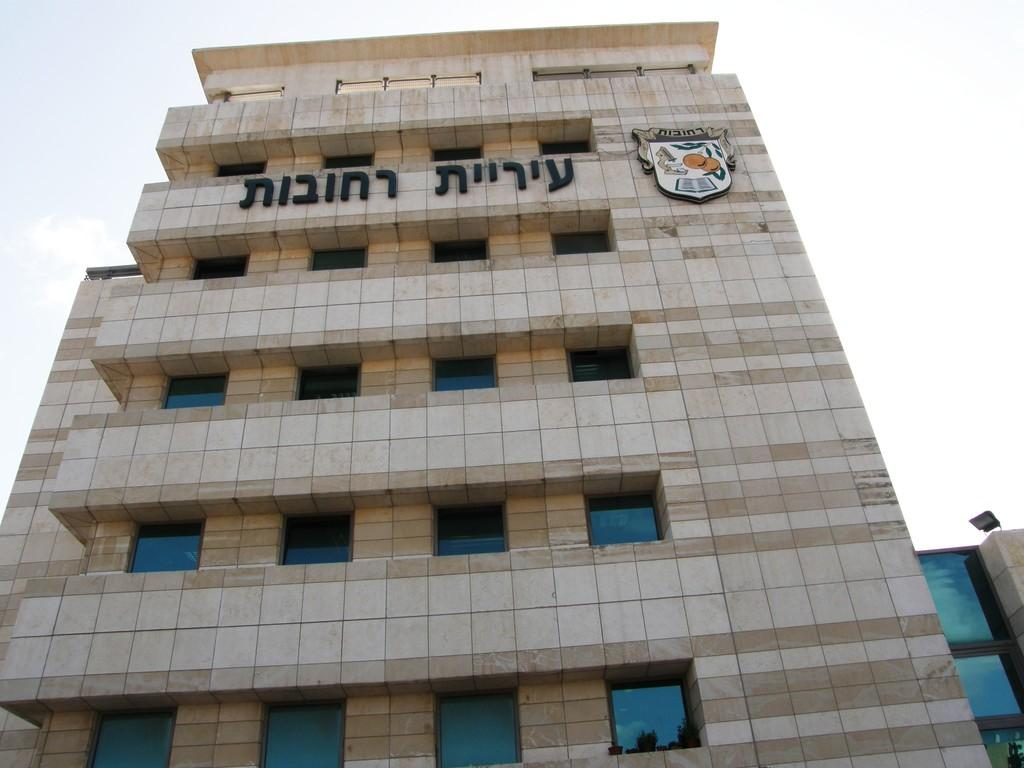What type of structure is in the image? There is a building in the image. What features can be seen on the building? The building has windows, text, and a logo. Can you describe the background of the image? There is a light and the sky visible in the background of the image. What time of day is it in the image, considering it's an afternoon scene? The provided facts do not mention the time of day or any indication of it being an afternoon scene. The image only shows a building with windows, text, and a logo, along with a light and the sky in the background. 